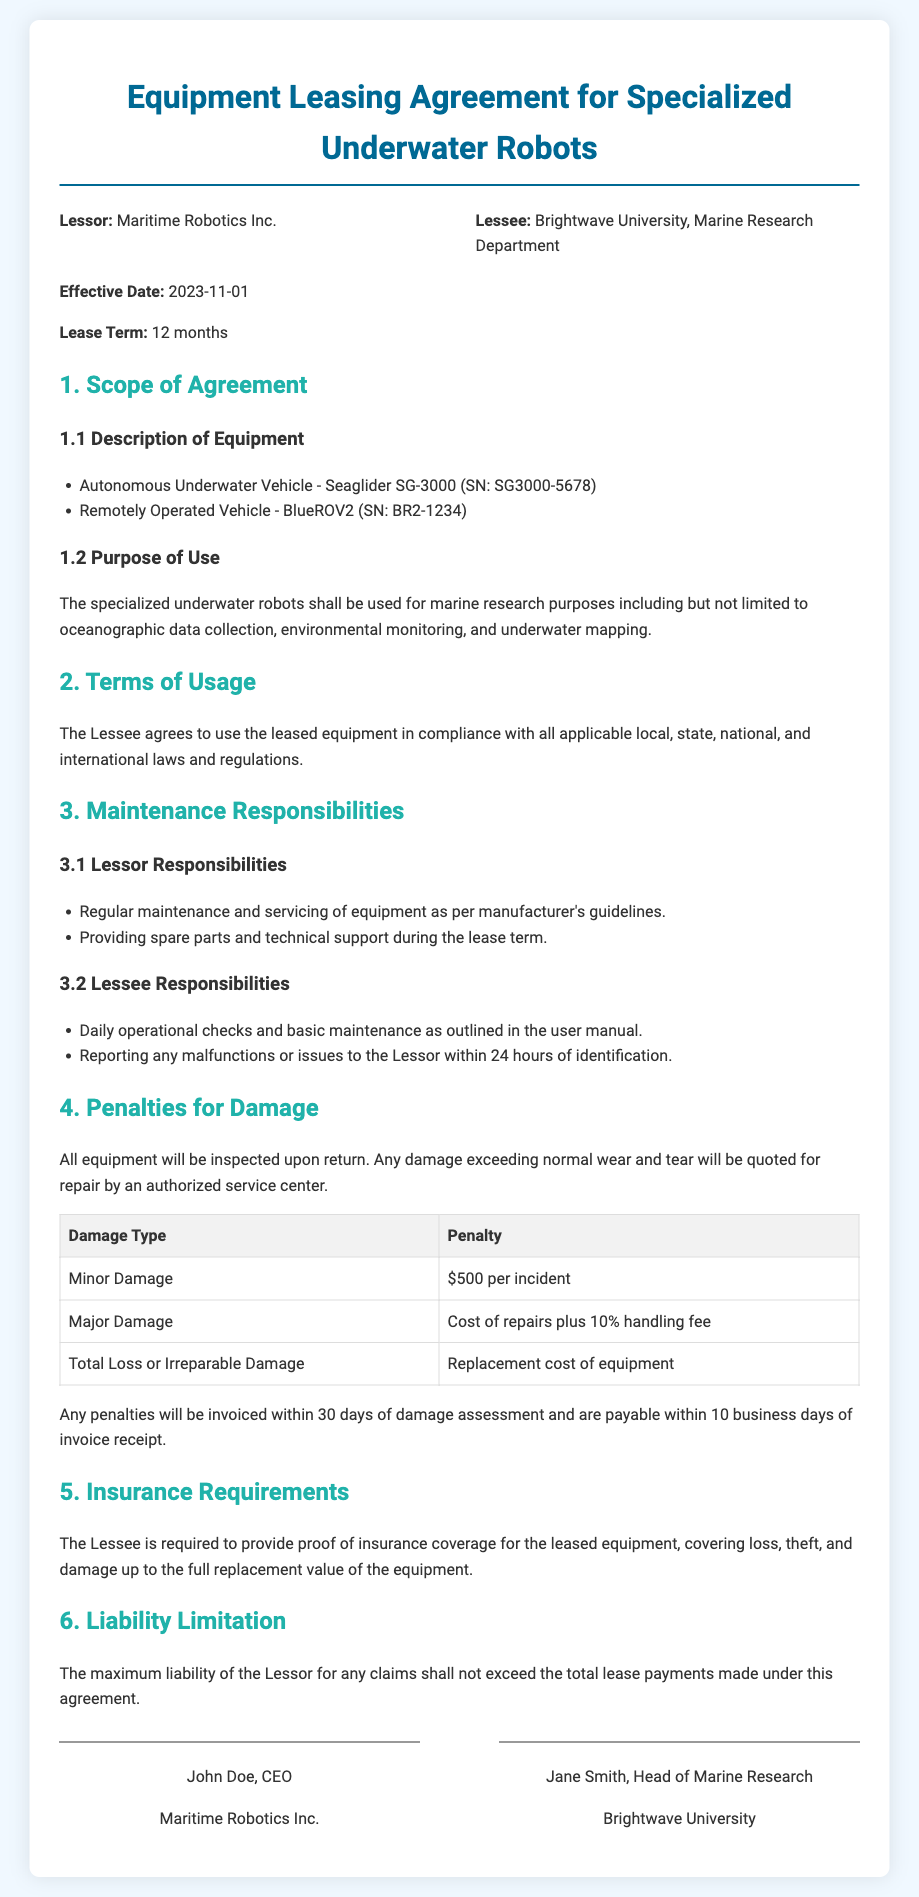What is the name of the Lessor? The Lessor is identified as Maritime Robotics Inc. in the contract.
Answer: Maritime Robotics Inc What is the effective date of the lease? The effective date is specified in the document as 2023-11-01.
Answer: 2023-11-01 How long is the lease term? The lease term is mentioned to be 12 months in the contract.
Answer: 12 months What type of equipment is the Seaglider SG-3000? The document classifies Seaglider SG-3000 as an Autonomous Underwater Vehicle.
Answer: Autonomous Underwater Vehicle What is the penalty for minor damage? The penalty for minor damage is stated in the document as $500 per incident.
Answer: $500 per incident What shall the Lessee do upon identifying a malfunction? The Lessee is required to report any malfunctions to the Lessor within 24 hours of identification.
Answer: Within 24 hours What insurance coverage must the Lessee provide? The Lessee must provide proof of insurance covering loss, theft, and damage up to full replacement value of the equipment.
Answer: Full replacement value What is the maximum liability of the Lessor? The maximum liability of the Lessor is limited to the total lease payments made under the agreement.
Answer: Total lease payments What happens if equipment is returned with major damage? Major damage will incur a charge for the cost of repairs plus a handling fee of 10%.
Answer: Cost of repairs plus 10% handling fee 